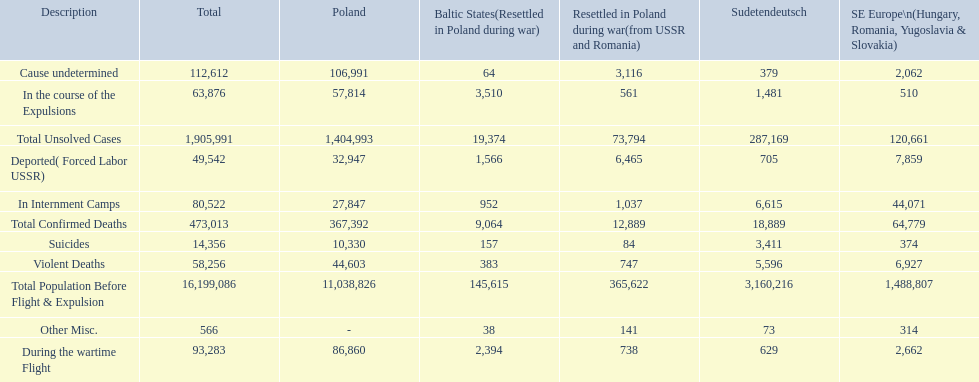What were all of the types of deaths? Violent Deaths, Suicides, Deported( Forced Labor USSR), In Internment Camps, During the wartime Flight, In the course of the Expulsions, Cause undetermined, Other Misc. And their totals in the baltic states? 383, 157, 1,566, 952, 2,394, 3,510, 64, 38. Were more deaths in the baltic states caused by undetermined causes or misc.? Cause undetermined. 